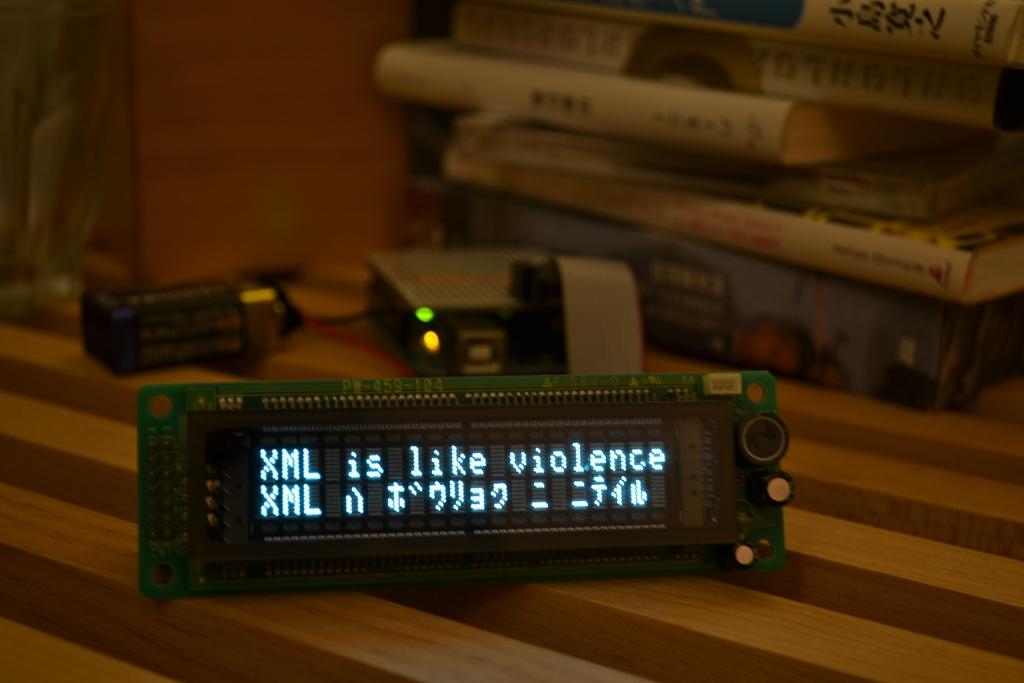<image>
Provide a brief description of the given image. An electronic LED display says XML is like violence. 